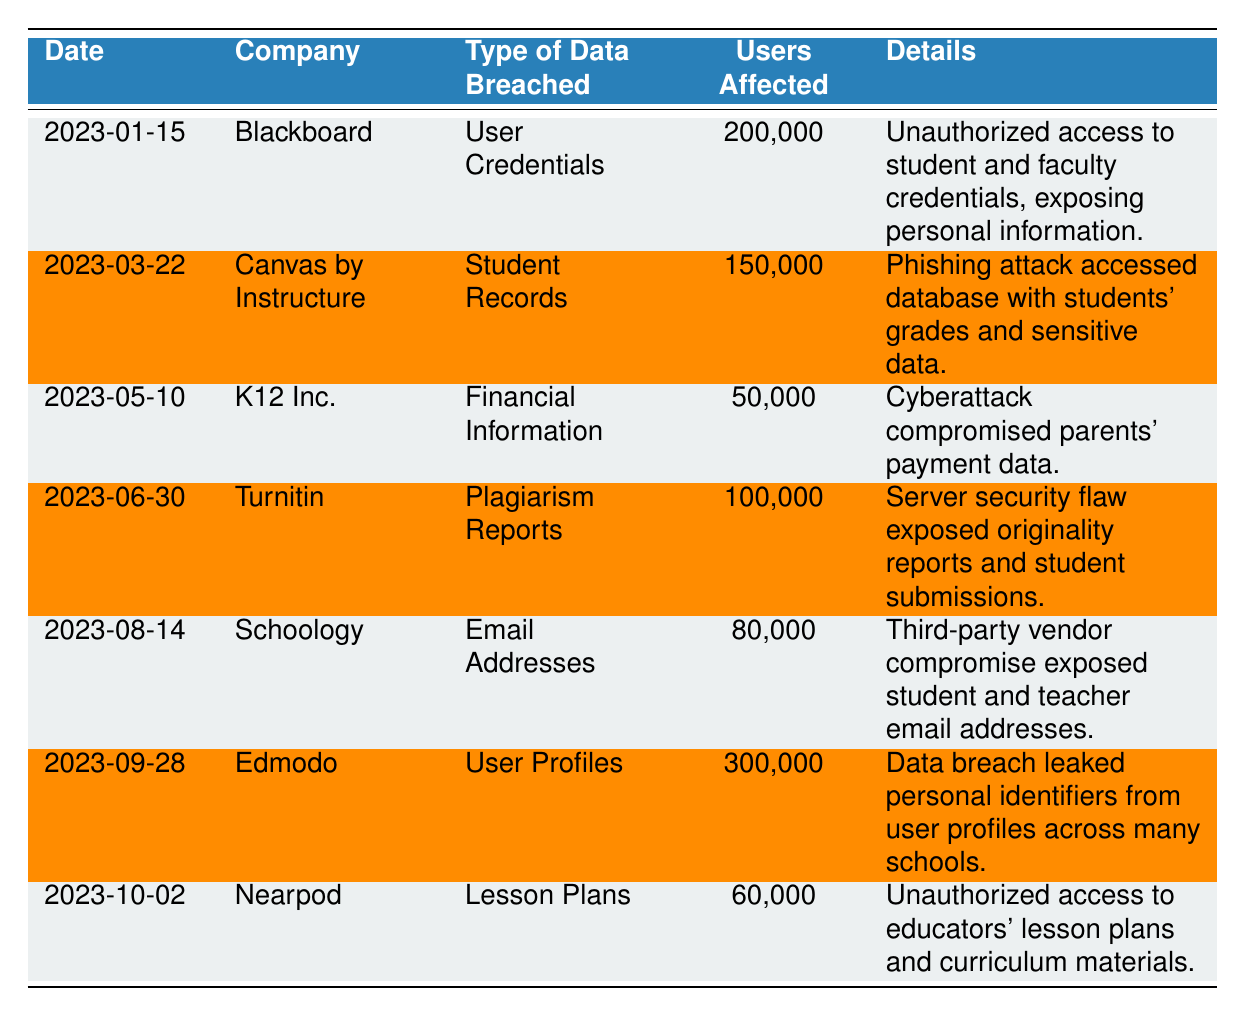What is the total number of users affected by data breaches in 2023? To find the total number of users affected, sum all the values in the "Number of Users Affected" column: 200,000 + 150,000 + 50,000 + 100,000 + 80,000 + 300,000 + 60,000 = 940,000.
Answer: 940,000 Which company had the highest number of users affected? Looking at the "Number of Users Affected" column, Edmodo has 300,000 users affected, which is the highest compared to the other companies listed.
Answer: Edmodo What type of data was breached for K12 Inc.? The "Type of Data Breached" for K12 Inc. is "Financial Information," as stated in the table.
Answer: Financial Information Did Schoology experience a breach of student records? The table indicates that Schoology's data breach was related to "Email Addresses," not student records, therefore the answer is no.
Answer: No Which incident happened on March 22, 2023? Referring to the table, on March 22, 2023, Canvas by Instructure experienced a breach of "Student Records."
Answer: Canvas by Instructure How many companies reported a data breach affecting more than 100,000 users? Reviewing the data, three companies reported breaches affecting over 100,000 users: Blackboard (200,000), Canvas by Instructure (150,000), and Edmodo (300,000), thus totaling three companies.
Answer: Three What was the common cause of the data breaches for Blackboard and Canvas by Instructure? Both Blackboard and Canvas by Instructure faced unauthorized access incidents; Blackboard's breach was due to unauthorized access to credentials and Canvas's breach was due to a phishing attack.
Answer: Unauthorized access What was the data type breached in the incident involving Turnitin? The "Type of Data Breached" for Turnitin is "Plagiarism Reports," as specified in the table.
Answer: Plagiarism Reports Which incident involved the leakage of information due to a third-party vendor compromise? The incident involving Schoology mentions a data breach due to a third-party vendor compromise that resulted in the exposure of email addresses.
Answer: Schoology What is the difference in the number of users affected between Edmodo and K12 Inc.? The number of users affected for Edmodo is 300,000, while for K12 Inc. it is 50,000. Therefore, the difference is 300,000 - 50,000 = 250,000.
Answer: 250,000 If you average the number of users affected by all incidents, what is the result? To find the average, sum the affected users (940,000) and divide by the number of incidents (7): 940,000 / 7 = 134,285.71. Thus, the average is approximately 134,286.
Answer: 134,286 